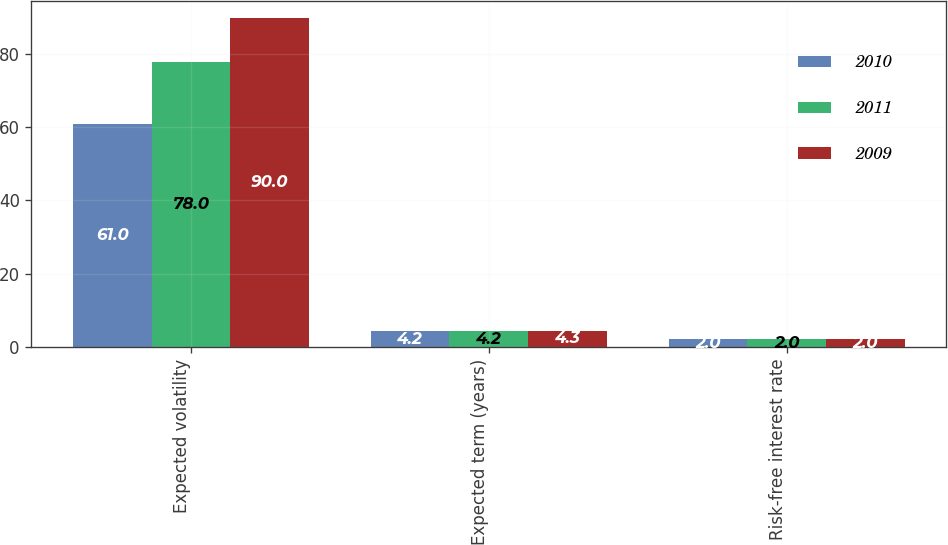Convert chart. <chart><loc_0><loc_0><loc_500><loc_500><stacked_bar_chart><ecel><fcel>Expected volatility<fcel>Expected term (years)<fcel>Risk-free interest rate<nl><fcel>2010<fcel>61<fcel>4.2<fcel>2<nl><fcel>2011<fcel>78<fcel>4.2<fcel>2<nl><fcel>2009<fcel>90<fcel>4.3<fcel>2<nl></chart> 